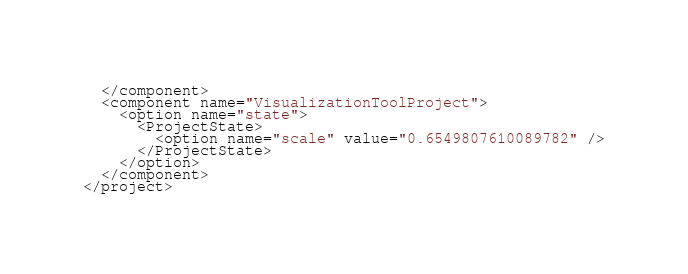<code> <loc_0><loc_0><loc_500><loc_500><_XML_>  </component>
  <component name="VisualizationToolProject">
    <option name="state">
      <ProjectState>
        <option name="scale" value="0.6549807610089782" />
      </ProjectState>
    </option>
  </component>
</project></code> 